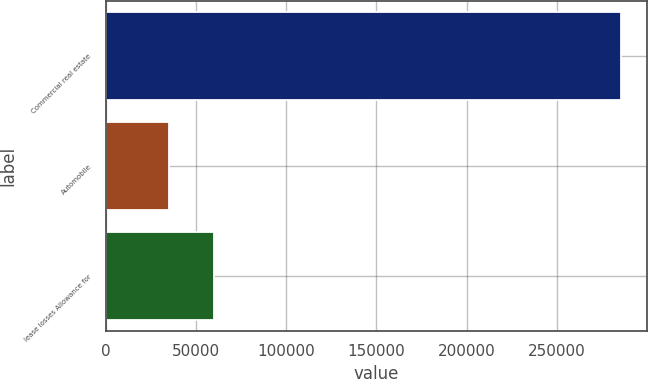<chart> <loc_0><loc_0><loc_500><loc_500><bar_chart><fcel>Commercial real estate<fcel>Automobile<fcel>lease losses Allowance for<nl><fcel>285369<fcel>34979<fcel>60018<nl></chart> 